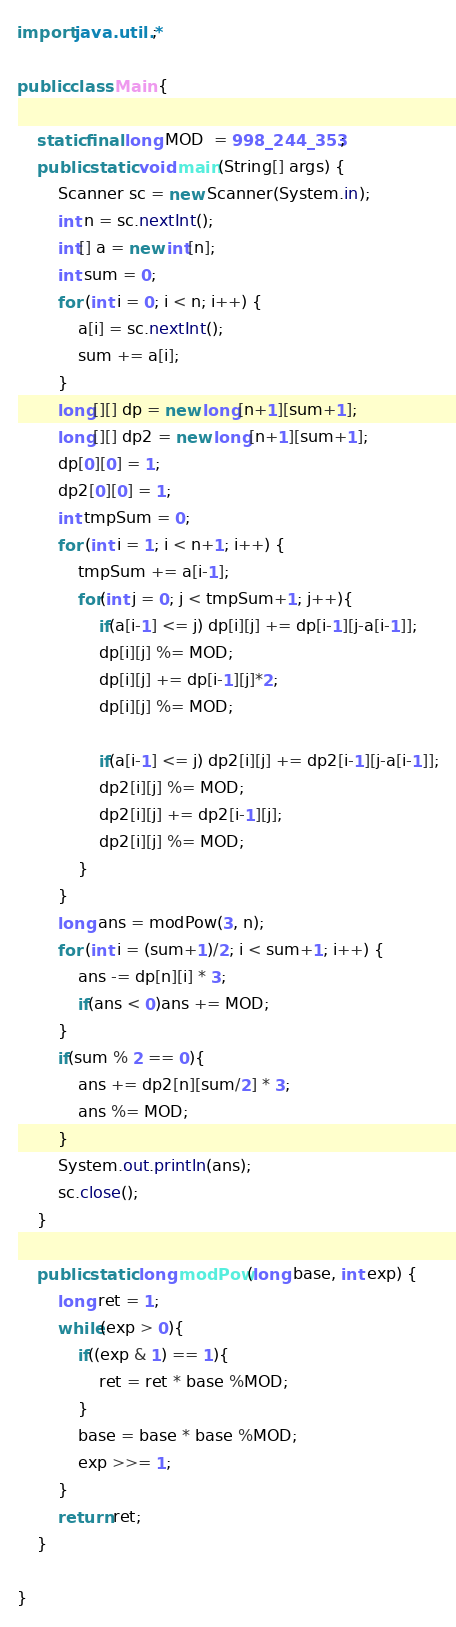Convert code to text. <code><loc_0><loc_0><loc_500><loc_500><_Java_>import java.util.*;

public class Main {

    static final long MOD  = 998_244_353;
    public static void main(String[] args) {
        Scanner sc = new Scanner(System.in);
        int n = sc.nextInt();
        int[] a = new int[n];
        int sum = 0;
        for (int i = 0; i < n; i++) {
            a[i] = sc.nextInt();
            sum += a[i];
        }
        long[][] dp = new long[n+1][sum+1];
        long[][] dp2 = new long[n+1][sum+1];
        dp[0][0] = 1;
        dp2[0][0] = 1;
        int tmpSum = 0;
        for (int i = 1; i < n+1; i++) {
            tmpSum += a[i-1];
            for(int j = 0; j < tmpSum+1; j++){
                if(a[i-1] <= j) dp[i][j] += dp[i-1][j-a[i-1]];
                dp[i][j] %= MOD;
                dp[i][j] += dp[i-1][j]*2;
                dp[i][j] %= MOD;

                if(a[i-1] <= j) dp2[i][j] += dp2[i-1][j-a[i-1]];
                dp2[i][j] %= MOD;
                dp2[i][j] += dp2[i-1][j];
                dp2[i][j] %= MOD;
            }
        }
        long ans = modPow(3, n);
        for (int i = (sum+1)/2; i < sum+1; i++) {
            ans -= dp[n][i] * 3;
            if(ans < 0)ans += MOD;
        }
        if(sum % 2 == 0){
            ans += dp2[n][sum/2] * 3;
            ans %= MOD;
        }
        System.out.println(ans);
        sc.close();
    }

    public static long modPow(long base, int exp) {
        long ret = 1;
        while(exp > 0){
            if((exp & 1) == 1){
                ret = ret * base %MOD;
            }
            base = base * base %MOD;
            exp >>= 1;
        }
        return ret;
    }

}
</code> 